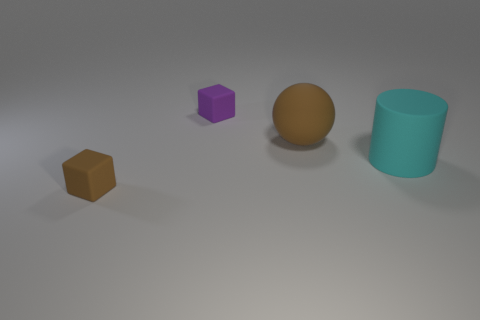Add 3 big rubber spheres. How many objects exist? 7 Subtract all spheres. How many objects are left? 3 Add 4 big blue metal objects. How many big blue metal objects exist? 4 Subtract 0 blue cylinders. How many objects are left? 4 Subtract all large cyan spheres. Subtract all big rubber objects. How many objects are left? 2 Add 2 spheres. How many spheres are left? 3 